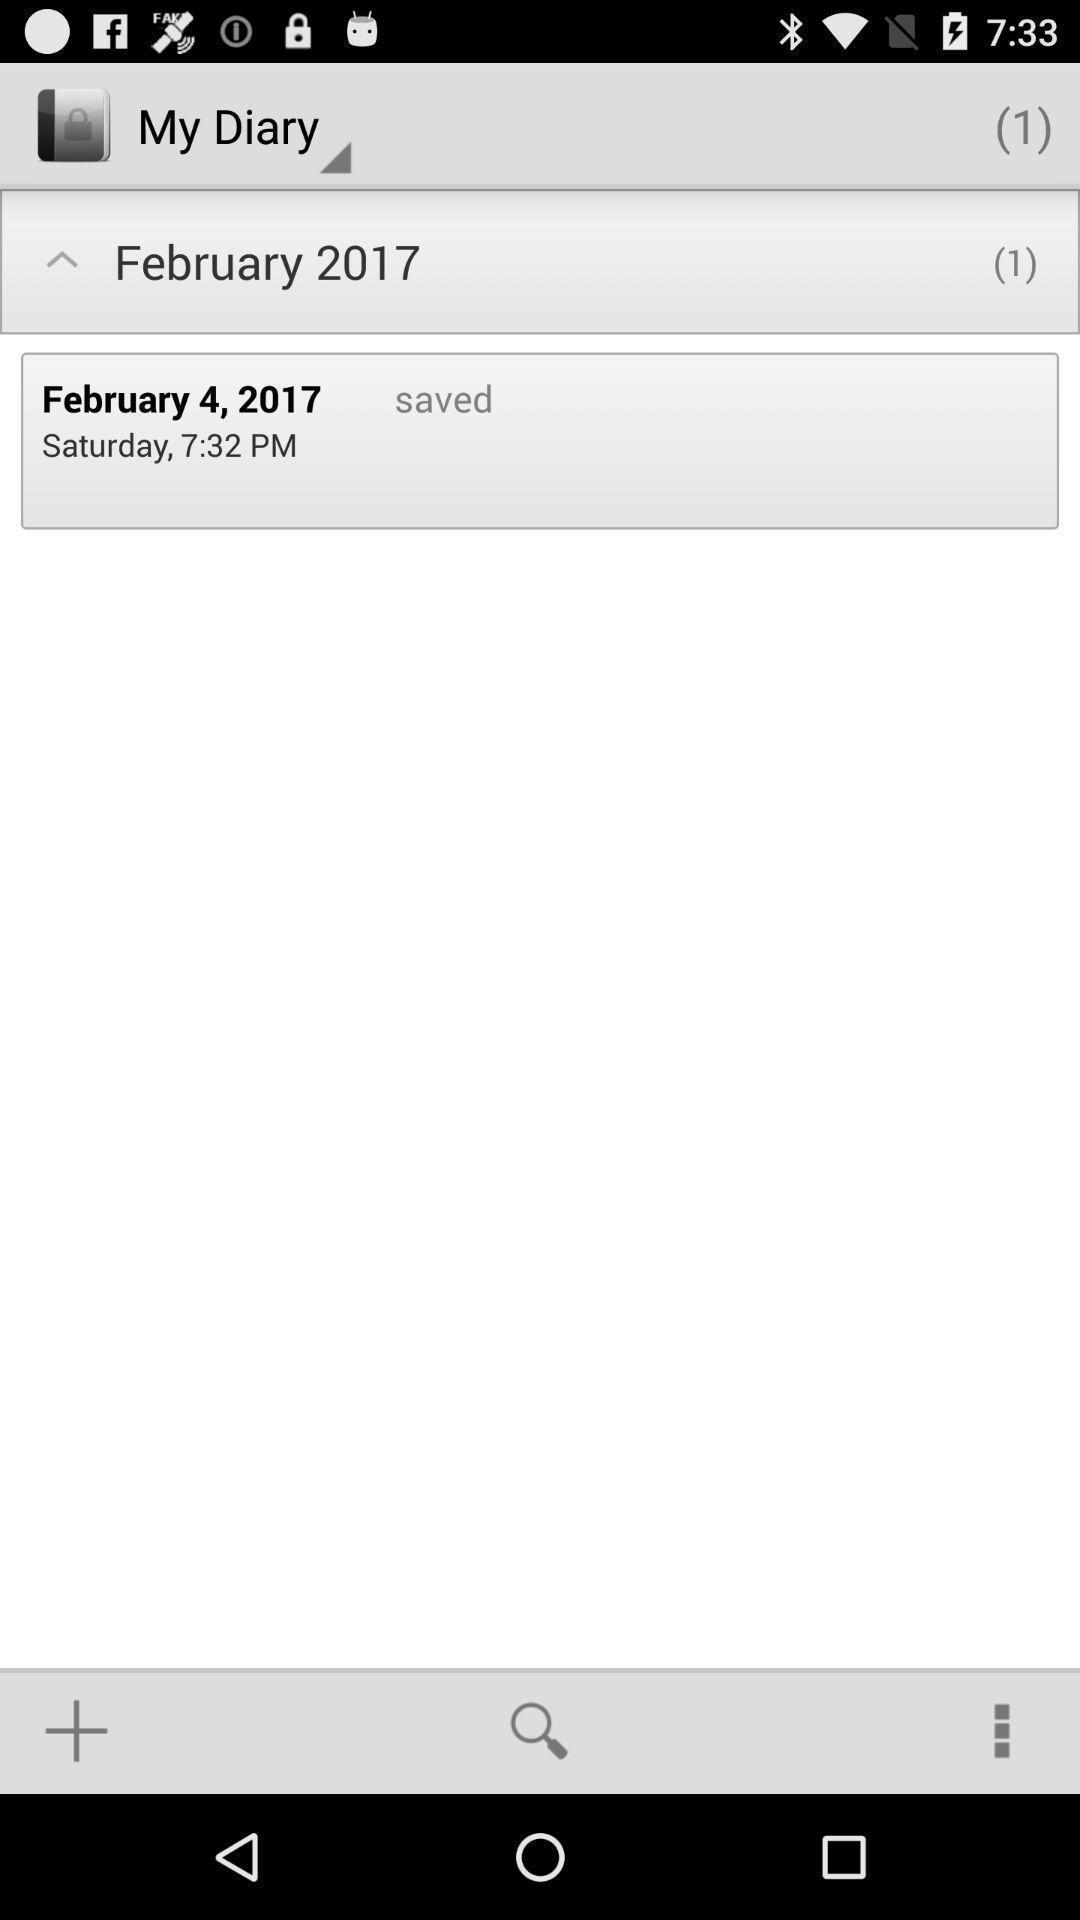What details can you identify in this image? Screen showing a saved record of a diary app. 